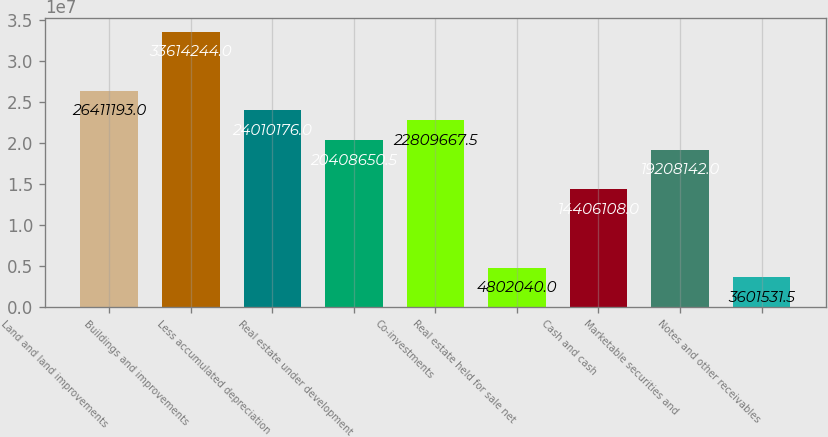Convert chart. <chart><loc_0><loc_0><loc_500><loc_500><bar_chart><fcel>Land and land improvements<fcel>Buildings and improvements<fcel>Less accumulated depreciation<fcel>Real estate under development<fcel>Co-investments<fcel>Real estate held for sale net<fcel>Cash and cash<fcel>Marketable securities and<fcel>Notes and other receivables<nl><fcel>2.64112e+07<fcel>3.36142e+07<fcel>2.40102e+07<fcel>2.04087e+07<fcel>2.28097e+07<fcel>4.80204e+06<fcel>1.44061e+07<fcel>1.92081e+07<fcel>3.60153e+06<nl></chart> 